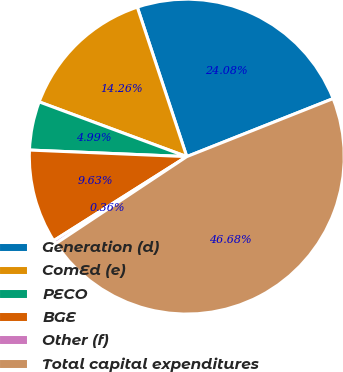<chart> <loc_0><loc_0><loc_500><loc_500><pie_chart><fcel>Generation (d)<fcel>ComEd (e)<fcel>PECO<fcel>BGE<fcel>Other (f)<fcel>Total capital expenditures<nl><fcel>24.08%<fcel>14.26%<fcel>4.99%<fcel>9.63%<fcel>0.36%<fcel>46.68%<nl></chart> 